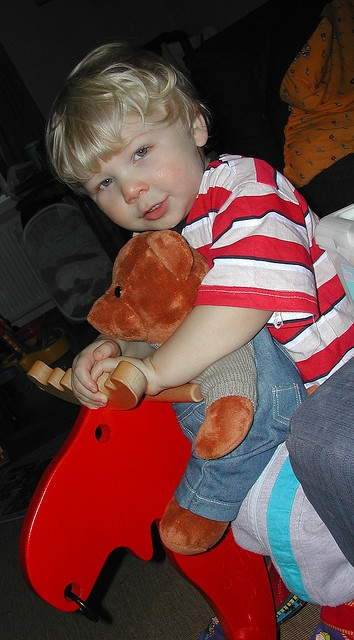Describe the objects in this image and their specific colors. I can see people in black, darkgray, lightgray, and gray tones and teddy bear in black, maroon, and brown tones in this image. 